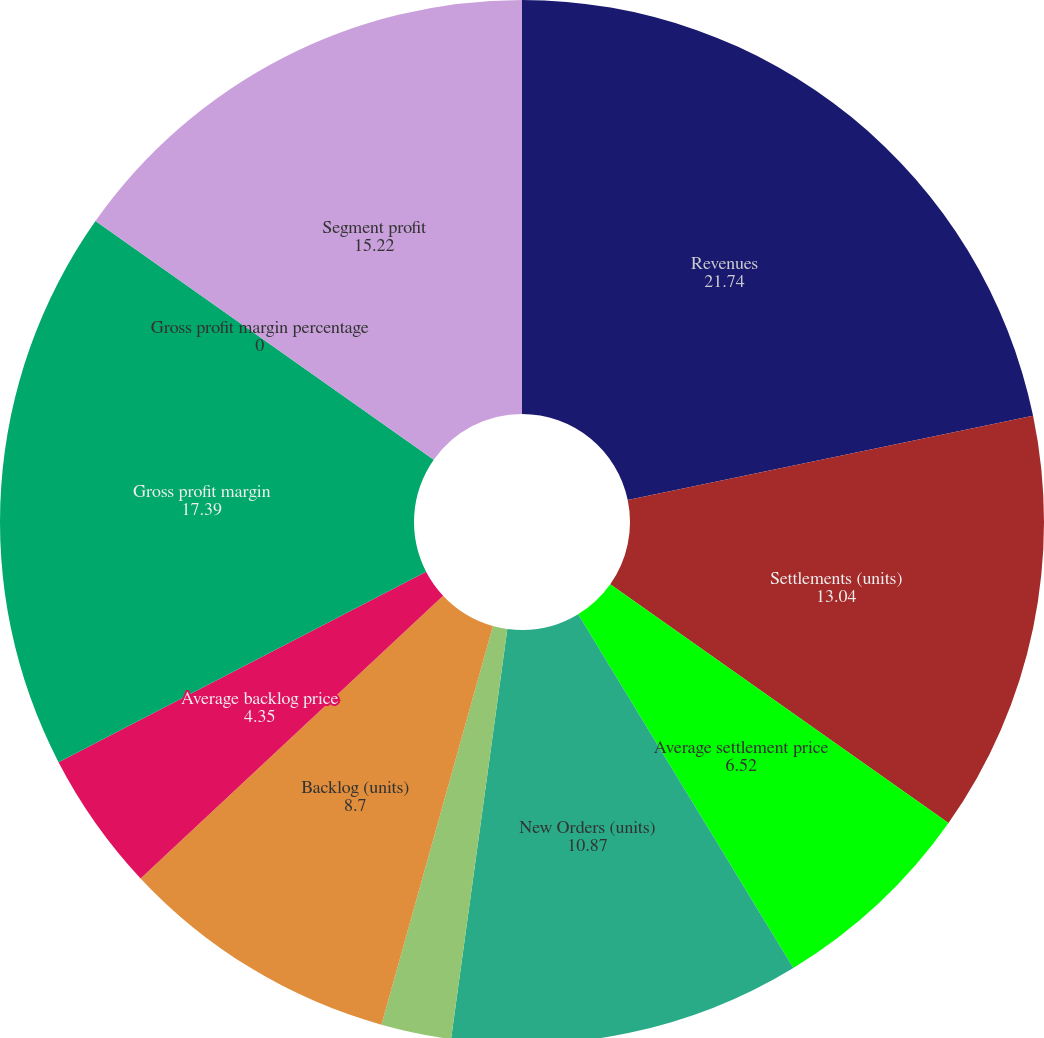Convert chart to OTSL. <chart><loc_0><loc_0><loc_500><loc_500><pie_chart><fcel>Revenues<fcel>Settlements (units)<fcel>Average settlement price<fcel>New Orders (units)<fcel>Average new order price<fcel>Backlog (units)<fcel>Average backlog price<fcel>Gross profit margin<fcel>Gross profit margin percentage<fcel>Segment profit<nl><fcel>21.74%<fcel>13.04%<fcel>6.52%<fcel>10.87%<fcel>2.17%<fcel>8.7%<fcel>4.35%<fcel>17.39%<fcel>0.0%<fcel>15.22%<nl></chart> 